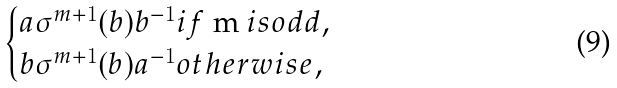Convert formula to latex. <formula><loc_0><loc_0><loc_500><loc_500>\begin{cases} a \sigma ^ { m + 1 } ( b ) b ^ { - 1 } i f $ m $ i s o d d , \\ b \sigma ^ { m + 1 } ( b ) a ^ { - 1 } o t h e r w i s e , \end{cases}</formula> 